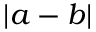Convert formula to latex. <formula><loc_0><loc_0><loc_500><loc_500>| a - b |</formula> 